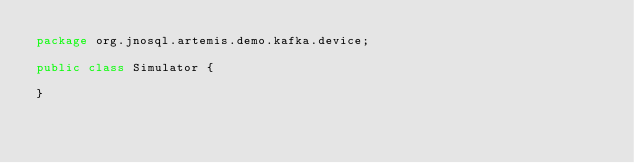Convert code to text. <code><loc_0><loc_0><loc_500><loc_500><_Java_>package org.jnosql.artemis.demo.kafka.device;

public class Simulator {

}
</code> 